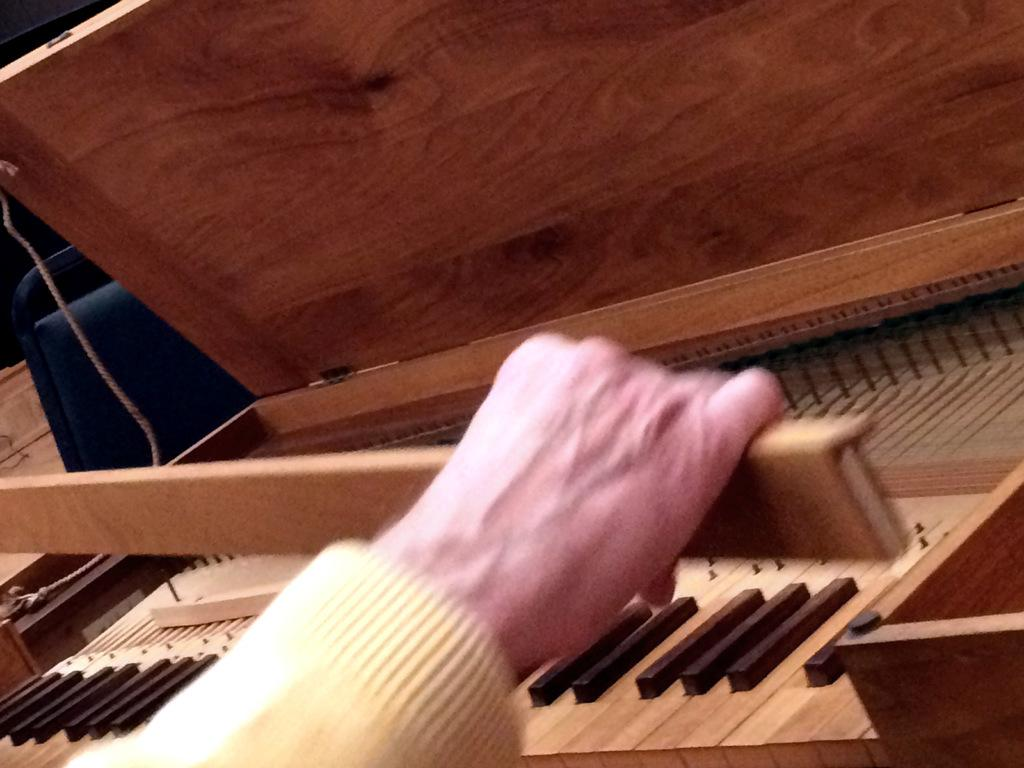What is the main subject of the image? There is a man in the image. What is the man holding in the image? The man is holding a stick. What other object can be seen in the image? There is a piano in the image. What type of bat is flying around the piano in the image? There is no bat present in the image; it only features a man holding a stick and a piano. 